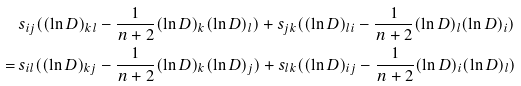Convert formula to latex. <formula><loc_0><loc_0><loc_500><loc_500>& s _ { i j } ( ( \ln D ) _ { k l } - \frac { 1 } { n + 2 } ( \ln D ) _ { k } ( \ln D ) _ { l } ) + s _ { j k } ( ( \ln D ) _ { l i } - \frac { 1 } { n + 2 } ( \ln D ) _ { l } ( \ln D ) _ { i } ) \\ = \ & s _ { i l } ( ( \ln D ) _ { k j } - \frac { 1 } { n + 2 } ( \ln D ) _ { k } ( \ln D ) _ { j } ) + s _ { l k } ( ( \ln D ) _ { i j } - \frac { 1 } { n + 2 } ( \ln D ) _ { i } ( \ln D ) _ { l } )</formula> 